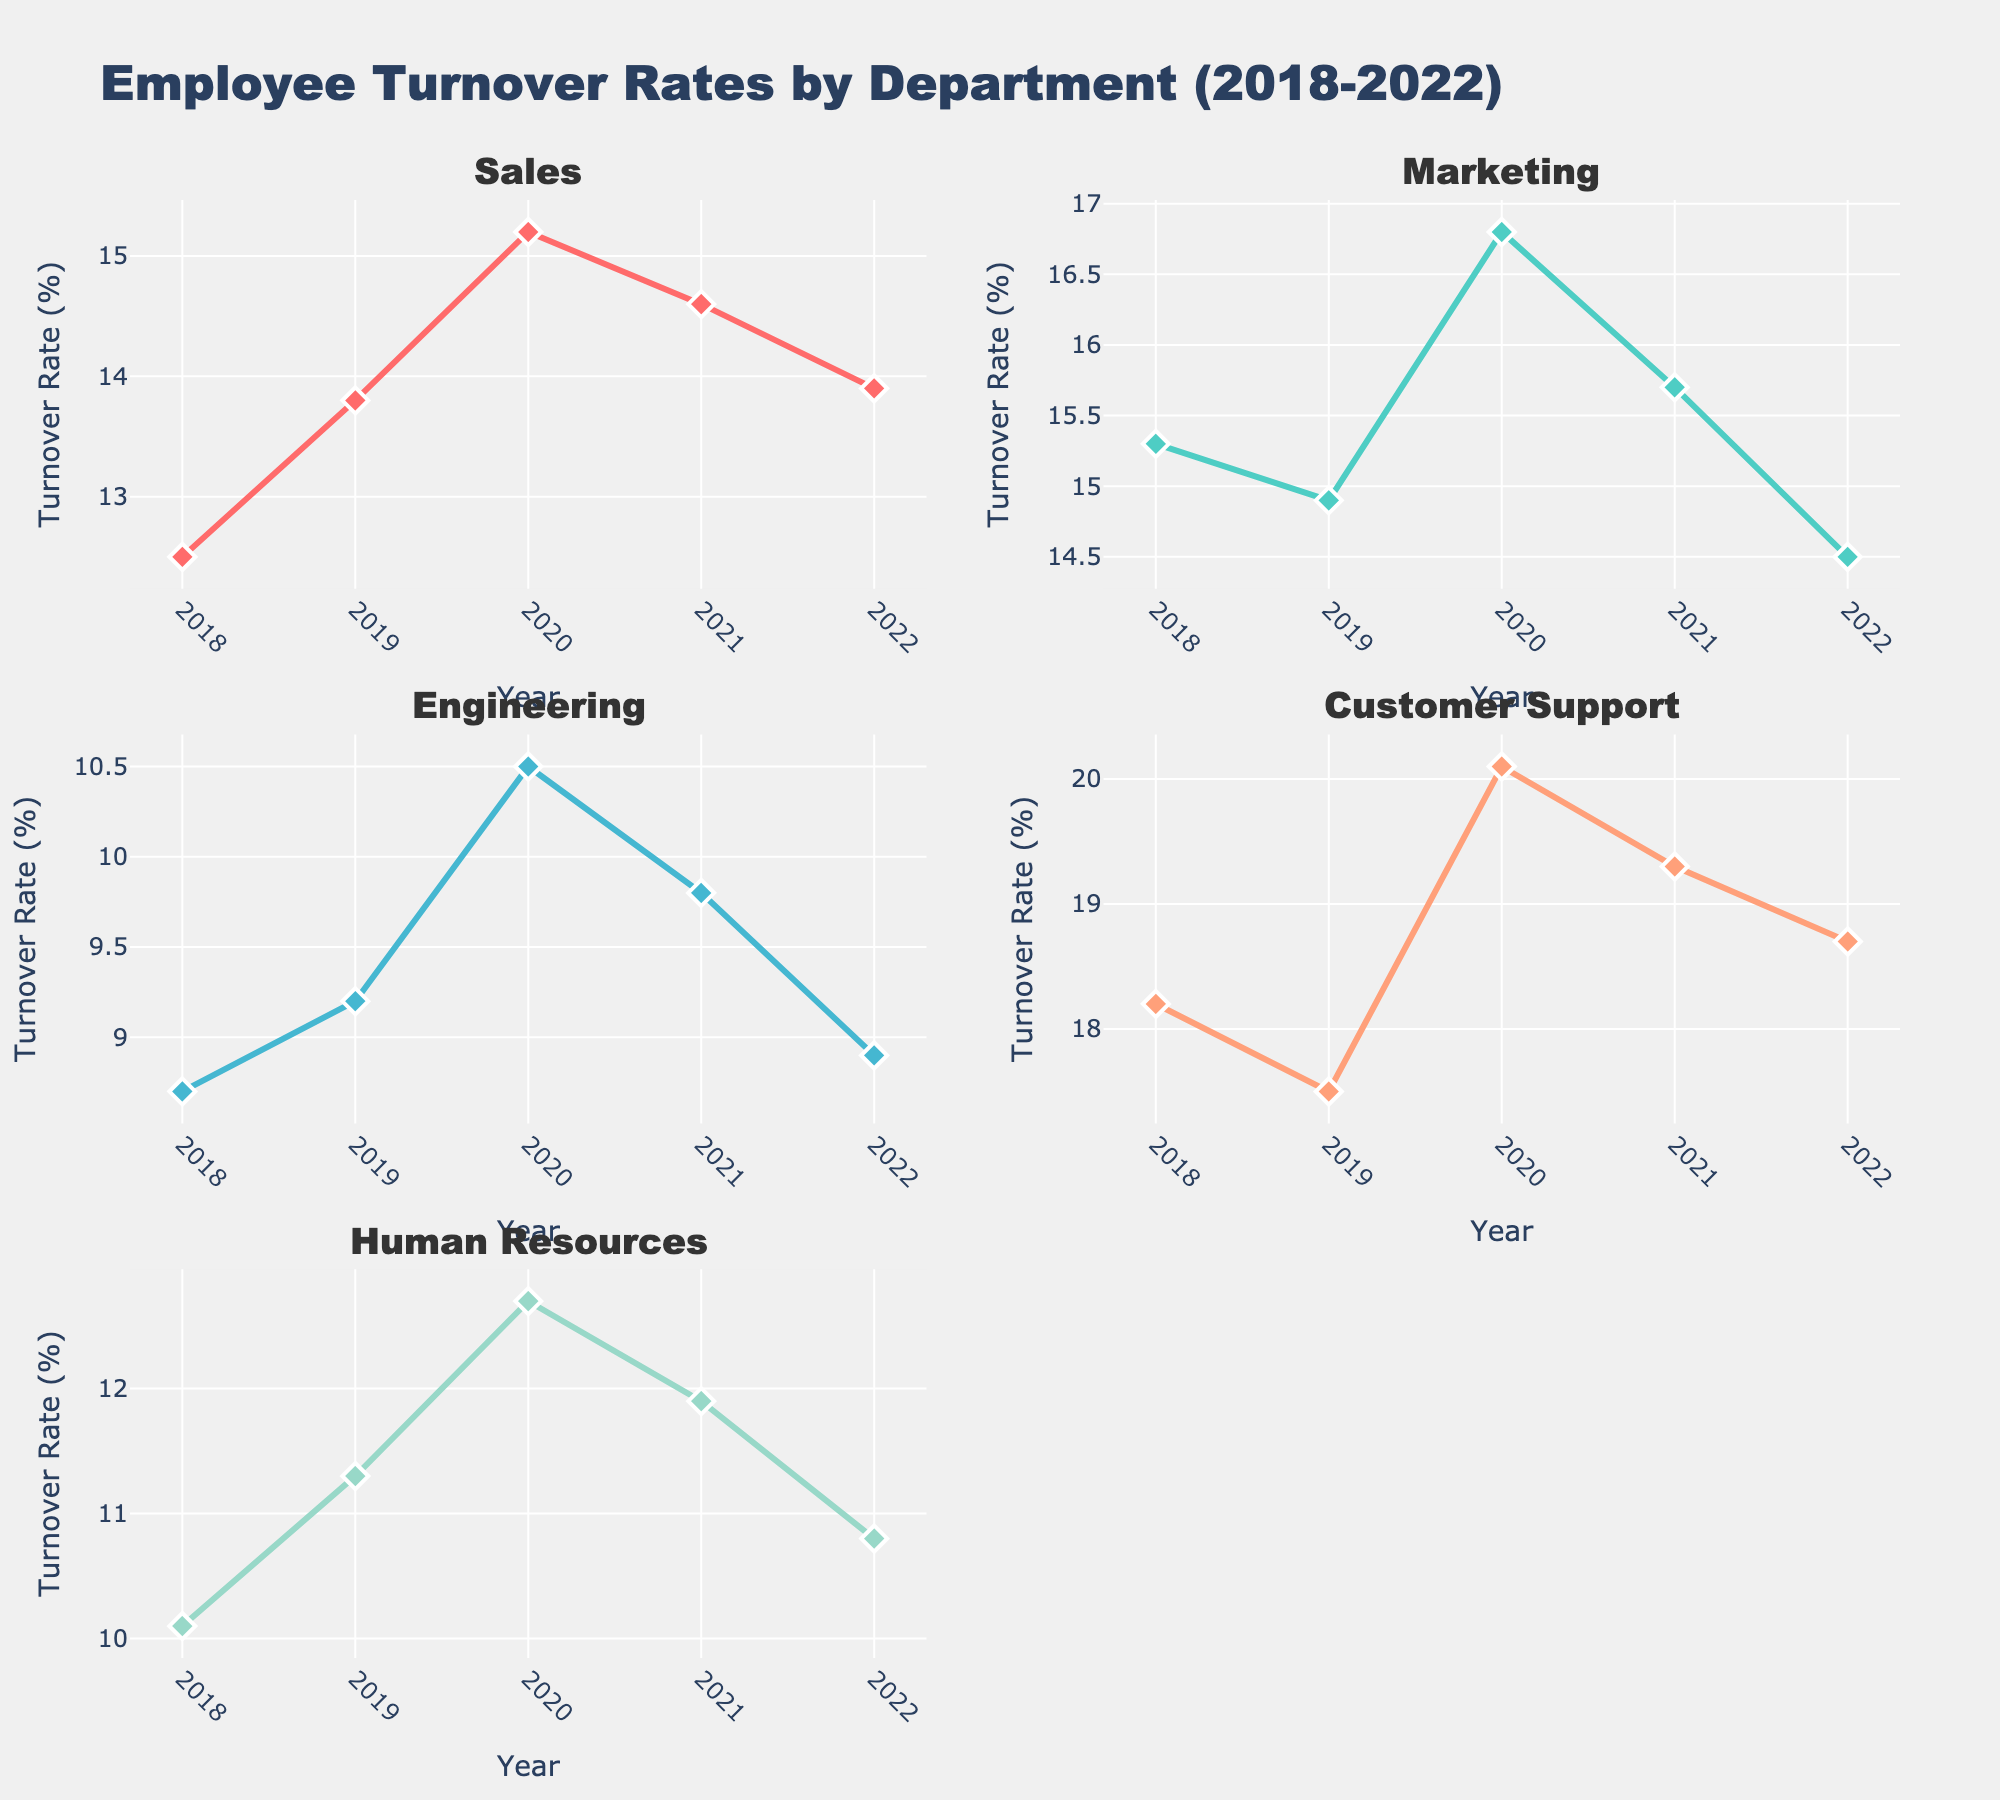How many years of data are shown in each subplot? The x-axis of each subplot is labeled with the years, and there are five distinct year labels: 2018, 2019, 2020, 2021, and 2022.
Answer: 5 Which department had the highest turnover rate in 2020? By examining the peaks in the line charts for 2020, the Customer Support department has the highest turnover rate, indicated by the highest point on the y-axis in that year.
Answer: Customer Support What was the turnover rate in Human Resources in 2021? Locate the line in the subplot for Human Resources at the year 2021. The point on the y-axis corresponding to that year is 11.9%.
Answer: 11.9% Can you identify any departments that had a decreasing turnover rate from 2020 to 2022? By observing the lines, Engineering and Human Resources both show a decreasing trend from 2020 to 2022 as their lines slope downward from 2020 to 2022.
Answer: Engineering, Human Resources Which department shows the most fluctuating turnover rate trend over the years? By examining the variance in the lines, Customer Support shows the most fluctuation with its turnover rate increasing and decreasing significantly over the years.
Answer: Customer Support Compare the turnover rates between Sales and Marketing in 2019. Which is higher? By looking at the line values for 2019, Marketing has a turnover rate of 14.9% and Sales has a turnover rate of 13.8%. Therefore, Marketing's rate is higher.
Answer: Marketing What is the average turnover rate for Engineering from 2018 to 2022? Adding the turnover rates for Engineering from 2018, 2019, 2020, 2021, and 2022: (8.7 + 9.2 + 10.5 + 9.8 + 8.9) = 47.1. Dividing by 5 gives the average: 47.1/5 = 9.42.
Answer: 9.42% Which department had a turnover rate of 18.2% in 2018? The subplot for Customer Support shows a data point at 18.2% for the year 2018.
Answer: Customer Support 